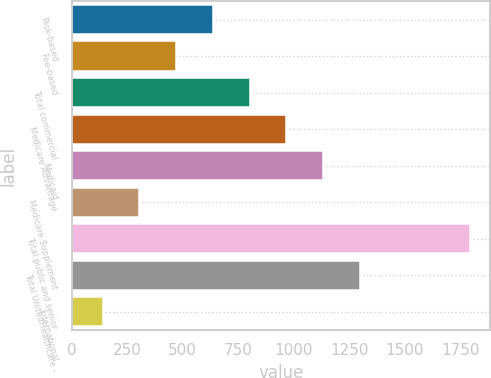<chart> <loc_0><loc_0><loc_500><loc_500><bar_chart><fcel>Risk-based<fcel>Fee-based<fcel>Total commercial<fcel>Medicare Advantage<fcel>Medicaid<fcel>Medicare Supplement<fcel>Total public and senior<fcel>Total UnitedHealthcare -<fcel>International<nl><fcel>636.5<fcel>471<fcel>802<fcel>967.5<fcel>1133<fcel>305.5<fcel>1795<fcel>1298.5<fcel>140<nl></chart> 